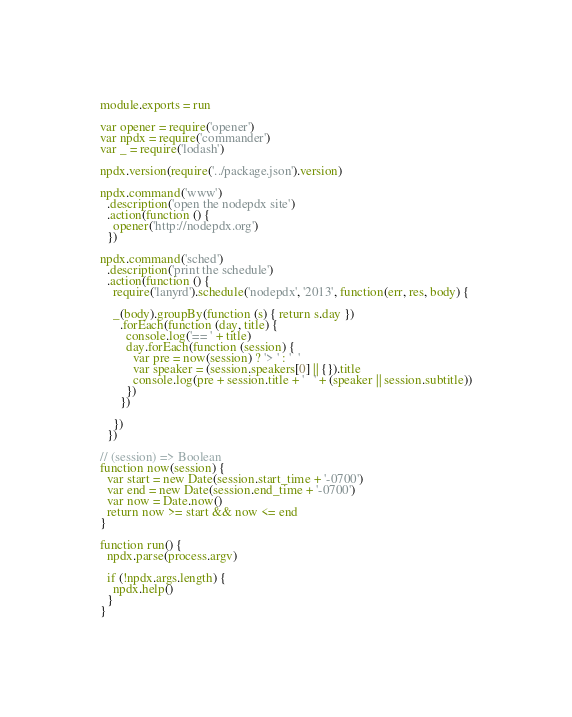<code> <loc_0><loc_0><loc_500><loc_500><_JavaScript_>module.exports = run

var opener = require('opener')
var npdx = require('commander')
var _ = require('lodash')

npdx.version(require('../package.json').version)

npdx.command('www')
  .description('open the nodepdx site')
  .action(function () {
    opener('http://nodepdx.org')
  })

npdx.command('sched')
  .description('print the schedule')
  .action(function () {
    require('lanyrd').schedule('nodepdx', '2013', function(err, res, body) {

    _(body).groupBy(function (s) { return s.day })
      .forEach(function (day, title) {
        console.log('== ' + title)
        day.forEach(function (session) {
          var pre = now(session) ? '> ' : '  '
          var speaker = (session.speakers[0] || {}).title
          console.log(pre + session.title + '   ' + (speaker || session.subtitle))
        })
      })

    })
  })

// (session) => Boolean
function now(session) {
  var start = new Date(session.start_time + '-0700')
  var end = new Date(session.end_time + '-0700')
  var now = Date.now()
  return now >= start && now <= end
}

function run() {
  npdx.parse(process.argv)

  if (!npdx.args.length) {
    npdx.help()
  }
}</code> 